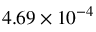<formula> <loc_0><loc_0><loc_500><loc_500>4 . 6 9 \times 1 0 ^ { - 4 }</formula> 